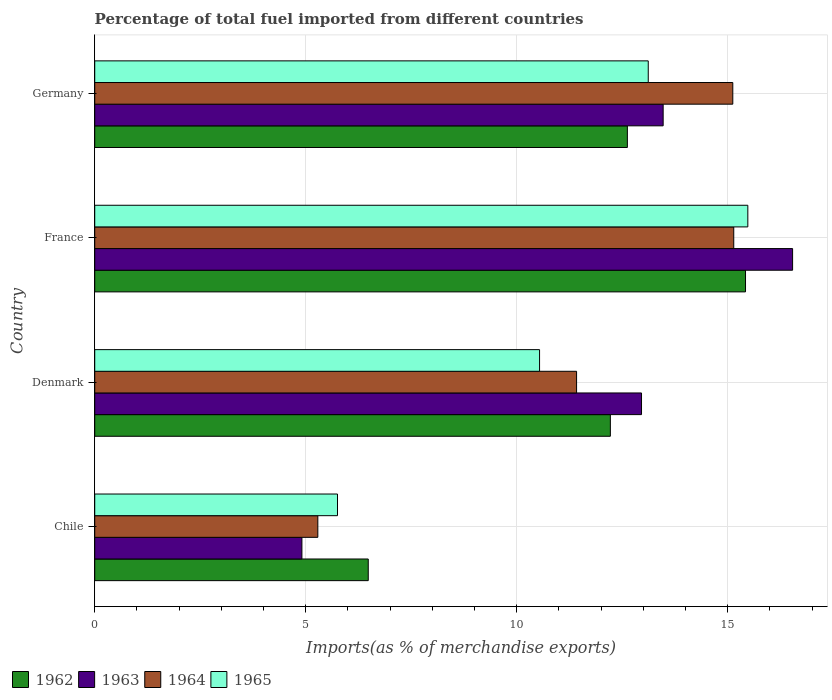Are the number of bars on each tick of the Y-axis equal?
Give a very brief answer. Yes. In how many cases, is the number of bars for a given country not equal to the number of legend labels?
Your response must be concise. 0. What is the percentage of imports to different countries in 1964 in Germany?
Your response must be concise. 15.12. Across all countries, what is the maximum percentage of imports to different countries in 1962?
Your answer should be compact. 15.42. Across all countries, what is the minimum percentage of imports to different countries in 1962?
Your response must be concise. 6.48. What is the total percentage of imports to different countries in 1965 in the graph?
Provide a succinct answer. 44.89. What is the difference between the percentage of imports to different countries in 1962 in Chile and that in France?
Provide a succinct answer. -8.94. What is the difference between the percentage of imports to different countries in 1965 in Chile and the percentage of imports to different countries in 1964 in Germany?
Your response must be concise. -9.37. What is the average percentage of imports to different countries in 1962 per country?
Ensure brevity in your answer.  11.69. What is the difference between the percentage of imports to different countries in 1964 and percentage of imports to different countries in 1965 in Germany?
Your answer should be very brief. 2. In how many countries, is the percentage of imports to different countries in 1963 greater than 11 %?
Offer a very short reply. 3. What is the ratio of the percentage of imports to different countries in 1964 in Chile to that in Denmark?
Your answer should be very brief. 0.46. Is the percentage of imports to different countries in 1964 in Chile less than that in France?
Provide a short and direct response. Yes. What is the difference between the highest and the second highest percentage of imports to different countries in 1965?
Your response must be concise. 2.36. What is the difference between the highest and the lowest percentage of imports to different countries in 1964?
Ensure brevity in your answer.  9.86. Is the sum of the percentage of imports to different countries in 1962 in Chile and Germany greater than the maximum percentage of imports to different countries in 1965 across all countries?
Your answer should be compact. Yes. What does the 1st bar from the top in Denmark represents?
Make the answer very short. 1965. What does the 3rd bar from the bottom in Denmark represents?
Your answer should be very brief. 1964. How many bars are there?
Provide a succinct answer. 16. What is the difference between two consecutive major ticks on the X-axis?
Provide a short and direct response. 5. Does the graph contain any zero values?
Offer a very short reply. No. Does the graph contain grids?
Your answer should be very brief. Yes. Where does the legend appear in the graph?
Ensure brevity in your answer.  Bottom left. How are the legend labels stacked?
Give a very brief answer. Horizontal. What is the title of the graph?
Keep it short and to the point. Percentage of total fuel imported from different countries. Does "1979" appear as one of the legend labels in the graph?
Your response must be concise. No. What is the label or title of the X-axis?
Make the answer very short. Imports(as % of merchandise exports). What is the label or title of the Y-axis?
Provide a succinct answer. Country. What is the Imports(as % of merchandise exports) in 1962 in Chile?
Keep it short and to the point. 6.48. What is the Imports(as % of merchandise exports) in 1963 in Chile?
Make the answer very short. 4.91. What is the Imports(as % of merchandise exports) in 1964 in Chile?
Your answer should be very brief. 5.29. What is the Imports(as % of merchandise exports) in 1965 in Chile?
Your answer should be very brief. 5.75. What is the Imports(as % of merchandise exports) in 1962 in Denmark?
Ensure brevity in your answer.  12.22. What is the Imports(as % of merchandise exports) of 1963 in Denmark?
Make the answer very short. 12.96. What is the Imports(as % of merchandise exports) in 1964 in Denmark?
Your answer should be very brief. 11.42. What is the Imports(as % of merchandise exports) in 1965 in Denmark?
Keep it short and to the point. 10.54. What is the Imports(as % of merchandise exports) in 1962 in France?
Provide a succinct answer. 15.42. What is the Imports(as % of merchandise exports) in 1963 in France?
Give a very brief answer. 16.54. What is the Imports(as % of merchandise exports) in 1964 in France?
Your response must be concise. 15.14. What is the Imports(as % of merchandise exports) of 1965 in France?
Make the answer very short. 15.48. What is the Imports(as % of merchandise exports) of 1962 in Germany?
Offer a very short reply. 12.62. What is the Imports(as % of merchandise exports) in 1963 in Germany?
Make the answer very short. 13.47. What is the Imports(as % of merchandise exports) of 1964 in Germany?
Your answer should be very brief. 15.12. What is the Imports(as % of merchandise exports) of 1965 in Germany?
Provide a short and direct response. 13.12. Across all countries, what is the maximum Imports(as % of merchandise exports) of 1962?
Your response must be concise. 15.42. Across all countries, what is the maximum Imports(as % of merchandise exports) in 1963?
Make the answer very short. 16.54. Across all countries, what is the maximum Imports(as % of merchandise exports) in 1964?
Make the answer very short. 15.14. Across all countries, what is the maximum Imports(as % of merchandise exports) in 1965?
Offer a very short reply. 15.48. Across all countries, what is the minimum Imports(as % of merchandise exports) in 1962?
Provide a succinct answer. 6.48. Across all countries, what is the minimum Imports(as % of merchandise exports) in 1963?
Ensure brevity in your answer.  4.91. Across all countries, what is the minimum Imports(as % of merchandise exports) of 1964?
Your answer should be very brief. 5.29. Across all countries, what is the minimum Imports(as % of merchandise exports) of 1965?
Provide a succinct answer. 5.75. What is the total Imports(as % of merchandise exports) in 1962 in the graph?
Provide a short and direct response. 46.75. What is the total Imports(as % of merchandise exports) in 1963 in the graph?
Provide a succinct answer. 47.88. What is the total Imports(as % of merchandise exports) of 1964 in the graph?
Your answer should be compact. 46.97. What is the total Imports(as % of merchandise exports) of 1965 in the graph?
Your response must be concise. 44.89. What is the difference between the Imports(as % of merchandise exports) in 1962 in Chile and that in Denmark?
Provide a short and direct response. -5.74. What is the difference between the Imports(as % of merchandise exports) in 1963 in Chile and that in Denmark?
Offer a very short reply. -8.05. What is the difference between the Imports(as % of merchandise exports) of 1964 in Chile and that in Denmark?
Give a very brief answer. -6.13. What is the difference between the Imports(as % of merchandise exports) in 1965 in Chile and that in Denmark?
Offer a terse response. -4.79. What is the difference between the Imports(as % of merchandise exports) of 1962 in Chile and that in France?
Keep it short and to the point. -8.94. What is the difference between the Imports(as % of merchandise exports) in 1963 in Chile and that in France?
Provide a short and direct response. -11.63. What is the difference between the Imports(as % of merchandise exports) of 1964 in Chile and that in France?
Your response must be concise. -9.86. What is the difference between the Imports(as % of merchandise exports) of 1965 in Chile and that in France?
Your response must be concise. -9.72. What is the difference between the Imports(as % of merchandise exports) in 1962 in Chile and that in Germany?
Your response must be concise. -6.14. What is the difference between the Imports(as % of merchandise exports) of 1963 in Chile and that in Germany?
Provide a short and direct response. -8.56. What is the difference between the Imports(as % of merchandise exports) of 1964 in Chile and that in Germany?
Your answer should be compact. -9.83. What is the difference between the Imports(as % of merchandise exports) in 1965 in Chile and that in Germany?
Your answer should be compact. -7.36. What is the difference between the Imports(as % of merchandise exports) of 1962 in Denmark and that in France?
Keep it short and to the point. -3.2. What is the difference between the Imports(as % of merchandise exports) of 1963 in Denmark and that in France?
Ensure brevity in your answer.  -3.58. What is the difference between the Imports(as % of merchandise exports) of 1964 in Denmark and that in France?
Offer a terse response. -3.72. What is the difference between the Imports(as % of merchandise exports) of 1965 in Denmark and that in France?
Offer a terse response. -4.94. What is the difference between the Imports(as % of merchandise exports) in 1962 in Denmark and that in Germany?
Make the answer very short. -0.4. What is the difference between the Imports(as % of merchandise exports) of 1963 in Denmark and that in Germany?
Make the answer very short. -0.51. What is the difference between the Imports(as % of merchandise exports) in 1964 in Denmark and that in Germany?
Provide a short and direct response. -3.7. What is the difference between the Imports(as % of merchandise exports) in 1965 in Denmark and that in Germany?
Ensure brevity in your answer.  -2.58. What is the difference between the Imports(as % of merchandise exports) of 1962 in France and that in Germany?
Ensure brevity in your answer.  2.8. What is the difference between the Imports(as % of merchandise exports) of 1963 in France and that in Germany?
Your answer should be compact. 3.07. What is the difference between the Imports(as % of merchandise exports) of 1964 in France and that in Germany?
Your response must be concise. 0.02. What is the difference between the Imports(as % of merchandise exports) in 1965 in France and that in Germany?
Offer a very short reply. 2.36. What is the difference between the Imports(as % of merchandise exports) of 1962 in Chile and the Imports(as % of merchandise exports) of 1963 in Denmark?
Your response must be concise. -6.48. What is the difference between the Imports(as % of merchandise exports) in 1962 in Chile and the Imports(as % of merchandise exports) in 1964 in Denmark?
Your answer should be compact. -4.94. What is the difference between the Imports(as % of merchandise exports) in 1962 in Chile and the Imports(as % of merchandise exports) in 1965 in Denmark?
Offer a very short reply. -4.06. What is the difference between the Imports(as % of merchandise exports) in 1963 in Chile and the Imports(as % of merchandise exports) in 1964 in Denmark?
Your answer should be very brief. -6.51. What is the difference between the Imports(as % of merchandise exports) of 1963 in Chile and the Imports(as % of merchandise exports) of 1965 in Denmark?
Your answer should be very brief. -5.63. What is the difference between the Imports(as % of merchandise exports) in 1964 in Chile and the Imports(as % of merchandise exports) in 1965 in Denmark?
Keep it short and to the point. -5.25. What is the difference between the Imports(as % of merchandise exports) in 1962 in Chile and the Imports(as % of merchandise exports) in 1963 in France?
Your answer should be compact. -10.06. What is the difference between the Imports(as % of merchandise exports) of 1962 in Chile and the Imports(as % of merchandise exports) of 1964 in France?
Keep it short and to the point. -8.66. What is the difference between the Imports(as % of merchandise exports) in 1962 in Chile and the Imports(as % of merchandise exports) in 1965 in France?
Your answer should be compact. -9. What is the difference between the Imports(as % of merchandise exports) of 1963 in Chile and the Imports(as % of merchandise exports) of 1964 in France?
Offer a very short reply. -10.23. What is the difference between the Imports(as % of merchandise exports) in 1963 in Chile and the Imports(as % of merchandise exports) in 1965 in France?
Offer a very short reply. -10.57. What is the difference between the Imports(as % of merchandise exports) in 1964 in Chile and the Imports(as % of merchandise exports) in 1965 in France?
Provide a succinct answer. -10.19. What is the difference between the Imports(as % of merchandise exports) of 1962 in Chile and the Imports(as % of merchandise exports) of 1963 in Germany?
Provide a succinct answer. -6.99. What is the difference between the Imports(as % of merchandise exports) of 1962 in Chile and the Imports(as % of merchandise exports) of 1964 in Germany?
Your response must be concise. -8.64. What is the difference between the Imports(as % of merchandise exports) in 1962 in Chile and the Imports(as % of merchandise exports) in 1965 in Germany?
Ensure brevity in your answer.  -6.64. What is the difference between the Imports(as % of merchandise exports) of 1963 in Chile and the Imports(as % of merchandise exports) of 1964 in Germany?
Your answer should be compact. -10.21. What is the difference between the Imports(as % of merchandise exports) of 1963 in Chile and the Imports(as % of merchandise exports) of 1965 in Germany?
Your answer should be very brief. -8.21. What is the difference between the Imports(as % of merchandise exports) of 1964 in Chile and the Imports(as % of merchandise exports) of 1965 in Germany?
Your response must be concise. -7.83. What is the difference between the Imports(as % of merchandise exports) of 1962 in Denmark and the Imports(as % of merchandise exports) of 1963 in France?
Make the answer very short. -4.32. What is the difference between the Imports(as % of merchandise exports) of 1962 in Denmark and the Imports(as % of merchandise exports) of 1964 in France?
Your answer should be very brief. -2.92. What is the difference between the Imports(as % of merchandise exports) of 1962 in Denmark and the Imports(as % of merchandise exports) of 1965 in France?
Give a very brief answer. -3.26. What is the difference between the Imports(as % of merchandise exports) of 1963 in Denmark and the Imports(as % of merchandise exports) of 1964 in France?
Your response must be concise. -2.19. What is the difference between the Imports(as % of merchandise exports) of 1963 in Denmark and the Imports(as % of merchandise exports) of 1965 in France?
Offer a terse response. -2.52. What is the difference between the Imports(as % of merchandise exports) of 1964 in Denmark and the Imports(as % of merchandise exports) of 1965 in France?
Provide a short and direct response. -4.06. What is the difference between the Imports(as % of merchandise exports) of 1962 in Denmark and the Imports(as % of merchandise exports) of 1963 in Germany?
Your answer should be compact. -1.25. What is the difference between the Imports(as % of merchandise exports) of 1962 in Denmark and the Imports(as % of merchandise exports) of 1964 in Germany?
Your response must be concise. -2.9. What is the difference between the Imports(as % of merchandise exports) in 1962 in Denmark and the Imports(as % of merchandise exports) in 1965 in Germany?
Offer a terse response. -0.9. What is the difference between the Imports(as % of merchandise exports) in 1963 in Denmark and the Imports(as % of merchandise exports) in 1964 in Germany?
Offer a terse response. -2.16. What is the difference between the Imports(as % of merchandise exports) of 1963 in Denmark and the Imports(as % of merchandise exports) of 1965 in Germany?
Make the answer very short. -0.16. What is the difference between the Imports(as % of merchandise exports) in 1964 in Denmark and the Imports(as % of merchandise exports) in 1965 in Germany?
Ensure brevity in your answer.  -1.7. What is the difference between the Imports(as % of merchandise exports) in 1962 in France and the Imports(as % of merchandise exports) in 1963 in Germany?
Your answer should be compact. 1.95. What is the difference between the Imports(as % of merchandise exports) of 1962 in France and the Imports(as % of merchandise exports) of 1964 in Germany?
Give a very brief answer. 0.3. What is the difference between the Imports(as % of merchandise exports) in 1962 in France and the Imports(as % of merchandise exports) in 1965 in Germany?
Keep it short and to the point. 2.31. What is the difference between the Imports(as % of merchandise exports) in 1963 in France and the Imports(as % of merchandise exports) in 1964 in Germany?
Your answer should be very brief. 1.42. What is the difference between the Imports(as % of merchandise exports) in 1963 in France and the Imports(as % of merchandise exports) in 1965 in Germany?
Your response must be concise. 3.42. What is the difference between the Imports(as % of merchandise exports) in 1964 in France and the Imports(as % of merchandise exports) in 1965 in Germany?
Give a very brief answer. 2.03. What is the average Imports(as % of merchandise exports) of 1962 per country?
Give a very brief answer. 11.69. What is the average Imports(as % of merchandise exports) in 1963 per country?
Offer a terse response. 11.97. What is the average Imports(as % of merchandise exports) in 1964 per country?
Make the answer very short. 11.74. What is the average Imports(as % of merchandise exports) of 1965 per country?
Ensure brevity in your answer.  11.22. What is the difference between the Imports(as % of merchandise exports) of 1962 and Imports(as % of merchandise exports) of 1963 in Chile?
Your answer should be very brief. 1.57. What is the difference between the Imports(as % of merchandise exports) in 1962 and Imports(as % of merchandise exports) in 1964 in Chile?
Provide a short and direct response. 1.19. What is the difference between the Imports(as % of merchandise exports) of 1962 and Imports(as % of merchandise exports) of 1965 in Chile?
Provide a short and direct response. 0.73. What is the difference between the Imports(as % of merchandise exports) of 1963 and Imports(as % of merchandise exports) of 1964 in Chile?
Provide a succinct answer. -0.38. What is the difference between the Imports(as % of merchandise exports) of 1963 and Imports(as % of merchandise exports) of 1965 in Chile?
Provide a succinct answer. -0.84. What is the difference between the Imports(as % of merchandise exports) of 1964 and Imports(as % of merchandise exports) of 1965 in Chile?
Provide a succinct answer. -0.47. What is the difference between the Imports(as % of merchandise exports) of 1962 and Imports(as % of merchandise exports) of 1963 in Denmark?
Ensure brevity in your answer.  -0.74. What is the difference between the Imports(as % of merchandise exports) in 1962 and Imports(as % of merchandise exports) in 1964 in Denmark?
Keep it short and to the point. 0.8. What is the difference between the Imports(as % of merchandise exports) of 1962 and Imports(as % of merchandise exports) of 1965 in Denmark?
Offer a very short reply. 1.68. What is the difference between the Imports(as % of merchandise exports) of 1963 and Imports(as % of merchandise exports) of 1964 in Denmark?
Your answer should be very brief. 1.54. What is the difference between the Imports(as % of merchandise exports) in 1963 and Imports(as % of merchandise exports) in 1965 in Denmark?
Make the answer very short. 2.42. What is the difference between the Imports(as % of merchandise exports) in 1964 and Imports(as % of merchandise exports) in 1965 in Denmark?
Your response must be concise. 0.88. What is the difference between the Imports(as % of merchandise exports) of 1962 and Imports(as % of merchandise exports) of 1963 in France?
Your answer should be very brief. -1.12. What is the difference between the Imports(as % of merchandise exports) of 1962 and Imports(as % of merchandise exports) of 1964 in France?
Your response must be concise. 0.28. What is the difference between the Imports(as % of merchandise exports) in 1962 and Imports(as % of merchandise exports) in 1965 in France?
Ensure brevity in your answer.  -0.05. What is the difference between the Imports(as % of merchandise exports) of 1963 and Imports(as % of merchandise exports) of 1964 in France?
Provide a succinct answer. 1.39. What is the difference between the Imports(as % of merchandise exports) of 1963 and Imports(as % of merchandise exports) of 1965 in France?
Your answer should be very brief. 1.06. What is the difference between the Imports(as % of merchandise exports) in 1964 and Imports(as % of merchandise exports) in 1965 in France?
Offer a very short reply. -0.33. What is the difference between the Imports(as % of merchandise exports) of 1962 and Imports(as % of merchandise exports) of 1963 in Germany?
Offer a very short reply. -0.85. What is the difference between the Imports(as % of merchandise exports) of 1962 and Imports(as % of merchandise exports) of 1964 in Germany?
Offer a very short reply. -2.5. What is the difference between the Imports(as % of merchandise exports) in 1962 and Imports(as % of merchandise exports) in 1965 in Germany?
Your answer should be very brief. -0.49. What is the difference between the Imports(as % of merchandise exports) in 1963 and Imports(as % of merchandise exports) in 1964 in Germany?
Give a very brief answer. -1.65. What is the difference between the Imports(as % of merchandise exports) of 1963 and Imports(as % of merchandise exports) of 1965 in Germany?
Offer a terse response. 0.35. What is the difference between the Imports(as % of merchandise exports) in 1964 and Imports(as % of merchandise exports) in 1965 in Germany?
Your answer should be compact. 2. What is the ratio of the Imports(as % of merchandise exports) in 1962 in Chile to that in Denmark?
Offer a very short reply. 0.53. What is the ratio of the Imports(as % of merchandise exports) of 1963 in Chile to that in Denmark?
Provide a short and direct response. 0.38. What is the ratio of the Imports(as % of merchandise exports) of 1964 in Chile to that in Denmark?
Ensure brevity in your answer.  0.46. What is the ratio of the Imports(as % of merchandise exports) in 1965 in Chile to that in Denmark?
Your answer should be very brief. 0.55. What is the ratio of the Imports(as % of merchandise exports) of 1962 in Chile to that in France?
Offer a terse response. 0.42. What is the ratio of the Imports(as % of merchandise exports) in 1963 in Chile to that in France?
Offer a very short reply. 0.3. What is the ratio of the Imports(as % of merchandise exports) of 1964 in Chile to that in France?
Your answer should be compact. 0.35. What is the ratio of the Imports(as % of merchandise exports) of 1965 in Chile to that in France?
Give a very brief answer. 0.37. What is the ratio of the Imports(as % of merchandise exports) of 1962 in Chile to that in Germany?
Offer a very short reply. 0.51. What is the ratio of the Imports(as % of merchandise exports) in 1963 in Chile to that in Germany?
Give a very brief answer. 0.36. What is the ratio of the Imports(as % of merchandise exports) of 1964 in Chile to that in Germany?
Provide a succinct answer. 0.35. What is the ratio of the Imports(as % of merchandise exports) in 1965 in Chile to that in Germany?
Your answer should be very brief. 0.44. What is the ratio of the Imports(as % of merchandise exports) of 1962 in Denmark to that in France?
Your answer should be compact. 0.79. What is the ratio of the Imports(as % of merchandise exports) in 1963 in Denmark to that in France?
Provide a short and direct response. 0.78. What is the ratio of the Imports(as % of merchandise exports) of 1964 in Denmark to that in France?
Keep it short and to the point. 0.75. What is the ratio of the Imports(as % of merchandise exports) of 1965 in Denmark to that in France?
Your answer should be compact. 0.68. What is the ratio of the Imports(as % of merchandise exports) of 1962 in Denmark to that in Germany?
Provide a succinct answer. 0.97. What is the ratio of the Imports(as % of merchandise exports) of 1963 in Denmark to that in Germany?
Offer a terse response. 0.96. What is the ratio of the Imports(as % of merchandise exports) of 1964 in Denmark to that in Germany?
Make the answer very short. 0.76. What is the ratio of the Imports(as % of merchandise exports) of 1965 in Denmark to that in Germany?
Ensure brevity in your answer.  0.8. What is the ratio of the Imports(as % of merchandise exports) in 1962 in France to that in Germany?
Keep it short and to the point. 1.22. What is the ratio of the Imports(as % of merchandise exports) in 1963 in France to that in Germany?
Your response must be concise. 1.23. What is the ratio of the Imports(as % of merchandise exports) of 1964 in France to that in Germany?
Make the answer very short. 1. What is the ratio of the Imports(as % of merchandise exports) of 1965 in France to that in Germany?
Make the answer very short. 1.18. What is the difference between the highest and the second highest Imports(as % of merchandise exports) of 1962?
Your response must be concise. 2.8. What is the difference between the highest and the second highest Imports(as % of merchandise exports) of 1963?
Give a very brief answer. 3.07. What is the difference between the highest and the second highest Imports(as % of merchandise exports) of 1964?
Ensure brevity in your answer.  0.02. What is the difference between the highest and the second highest Imports(as % of merchandise exports) in 1965?
Provide a short and direct response. 2.36. What is the difference between the highest and the lowest Imports(as % of merchandise exports) of 1962?
Give a very brief answer. 8.94. What is the difference between the highest and the lowest Imports(as % of merchandise exports) in 1963?
Your response must be concise. 11.63. What is the difference between the highest and the lowest Imports(as % of merchandise exports) in 1964?
Your response must be concise. 9.86. What is the difference between the highest and the lowest Imports(as % of merchandise exports) in 1965?
Provide a succinct answer. 9.72. 